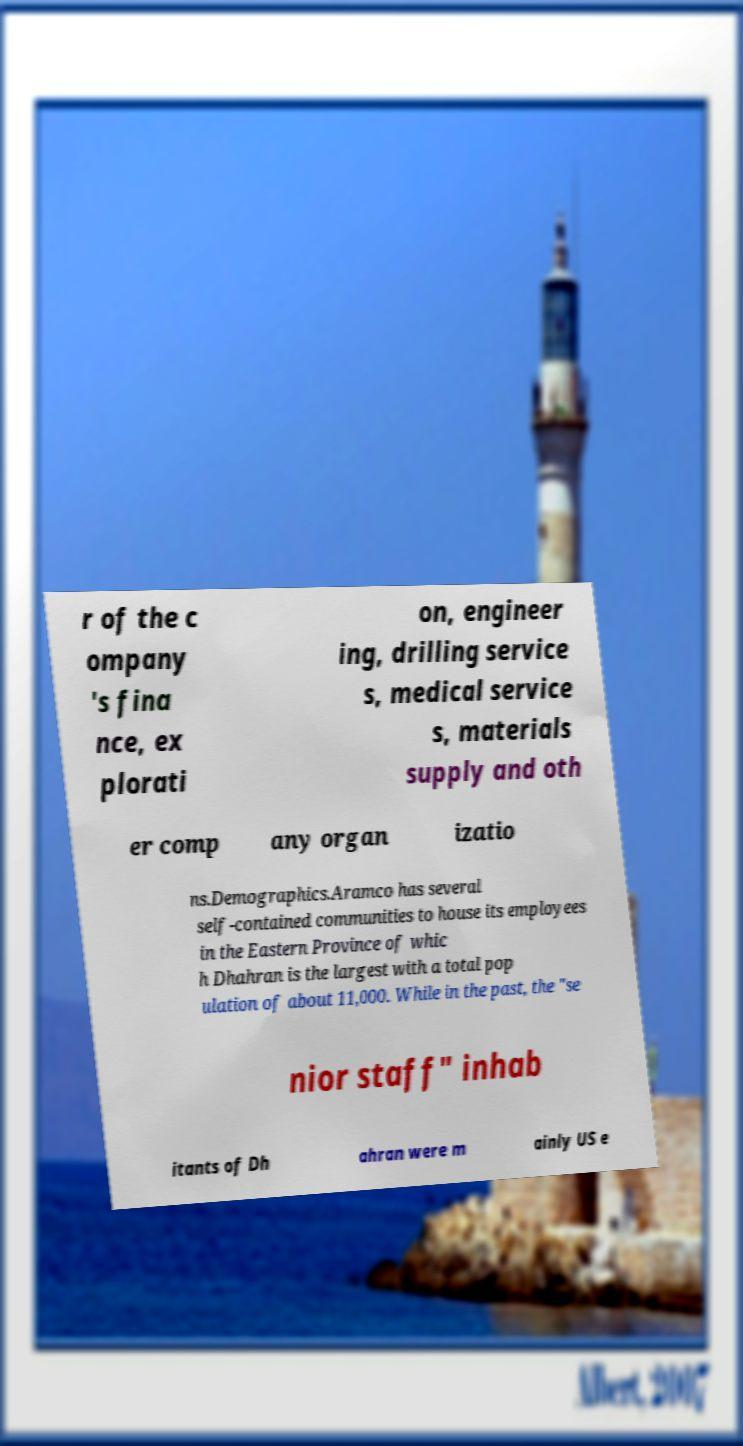For documentation purposes, I need the text within this image transcribed. Could you provide that? r of the c ompany 's fina nce, ex plorati on, engineer ing, drilling service s, medical service s, materials supply and oth er comp any organ izatio ns.Demographics.Aramco has several self-contained communities to house its employees in the Eastern Province of whic h Dhahran is the largest with a total pop ulation of about 11,000. While in the past, the "se nior staff" inhab itants of Dh ahran were m ainly US e 